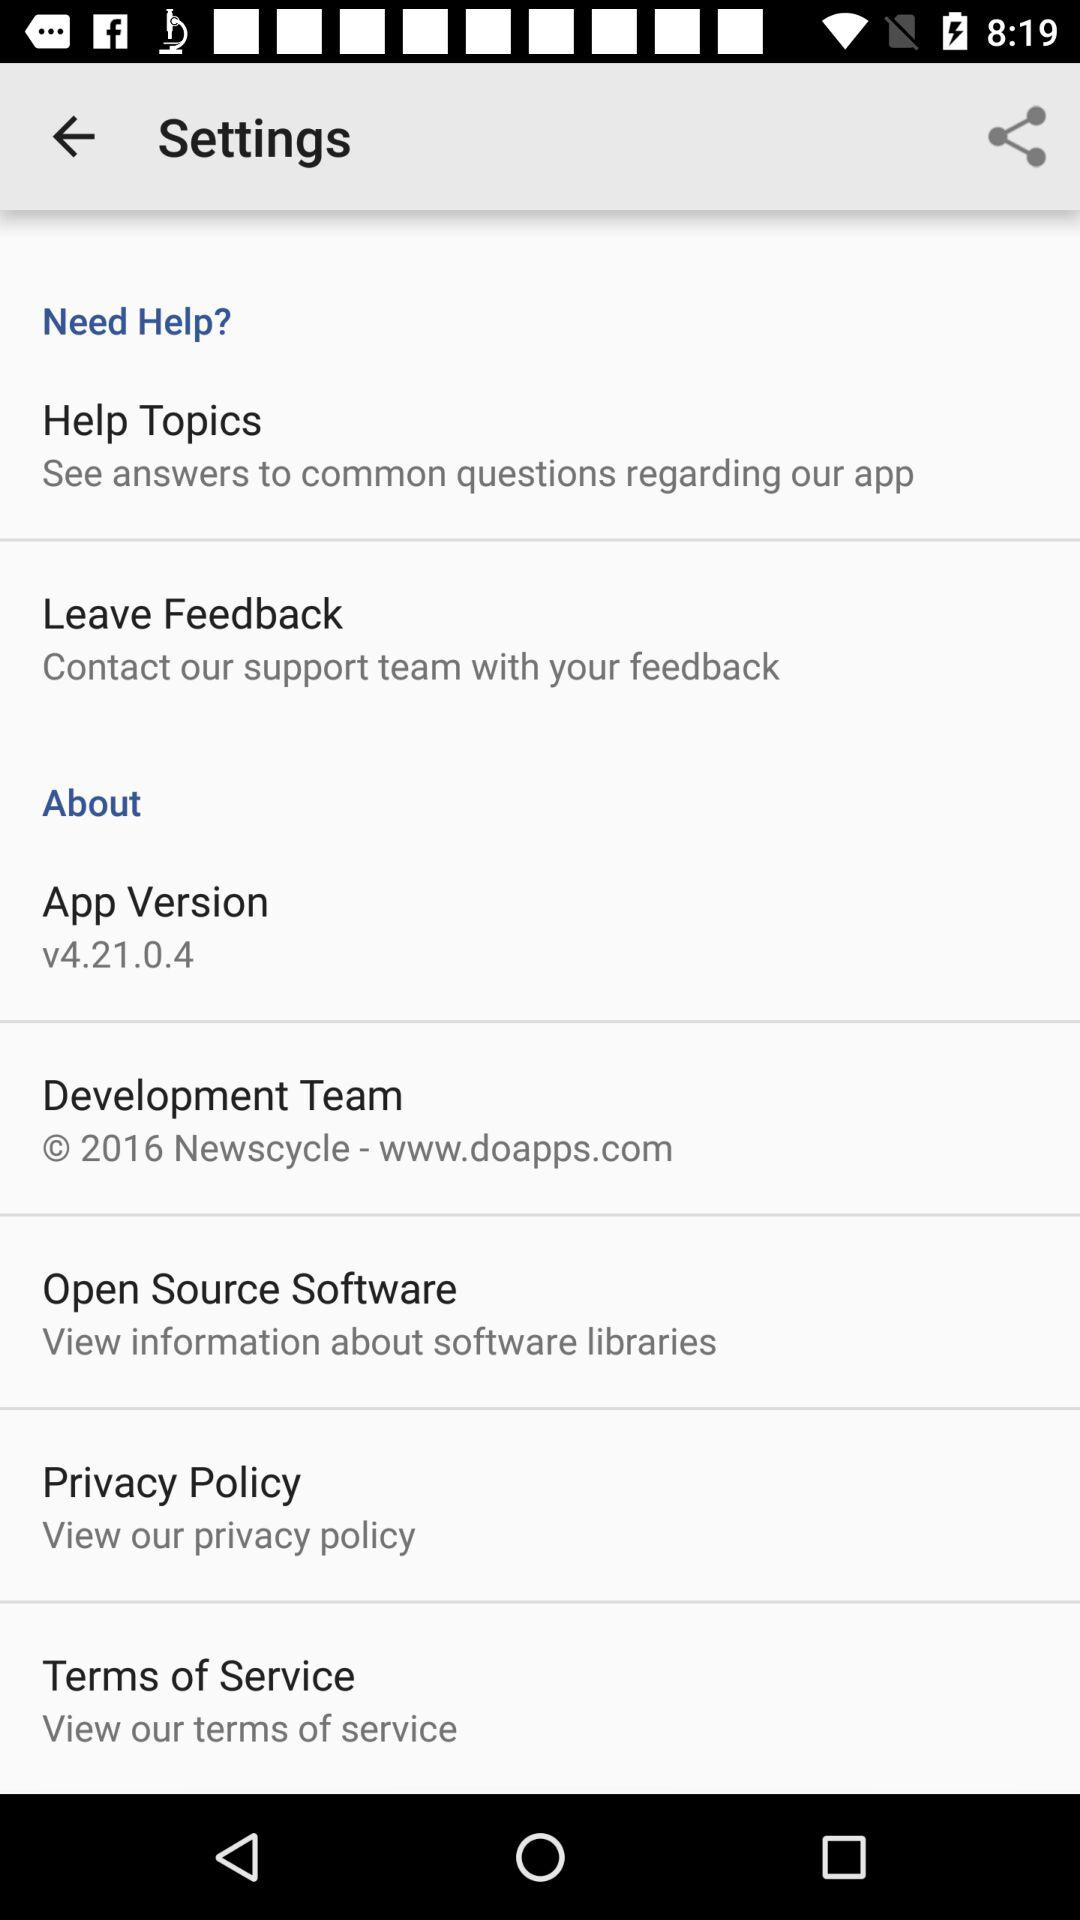What does the privacy policy say?
When the provided information is insufficient, respond with <no answer>. <no answer> 